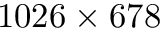Convert formula to latex. <formula><loc_0><loc_0><loc_500><loc_500>1 0 2 6 \times 6 7 8</formula> 